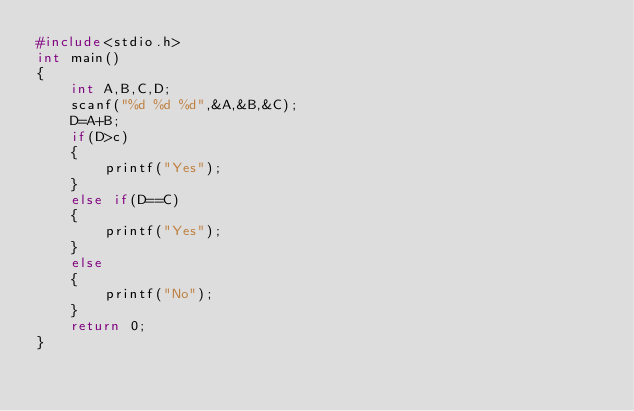Convert code to text. <code><loc_0><loc_0><loc_500><loc_500><_C_>#include<stdio.h>
int main()
{
    int A,B,C,D;
    scanf("%d %d %d",&A,&B,&C);
    D=A+B;
    if(D>c)
    {
        printf("Yes");
    }
    else if(D==C)
    {
        printf("Yes");
    }
    else
    {
        printf("No");
    }
    return 0;
}
</code> 